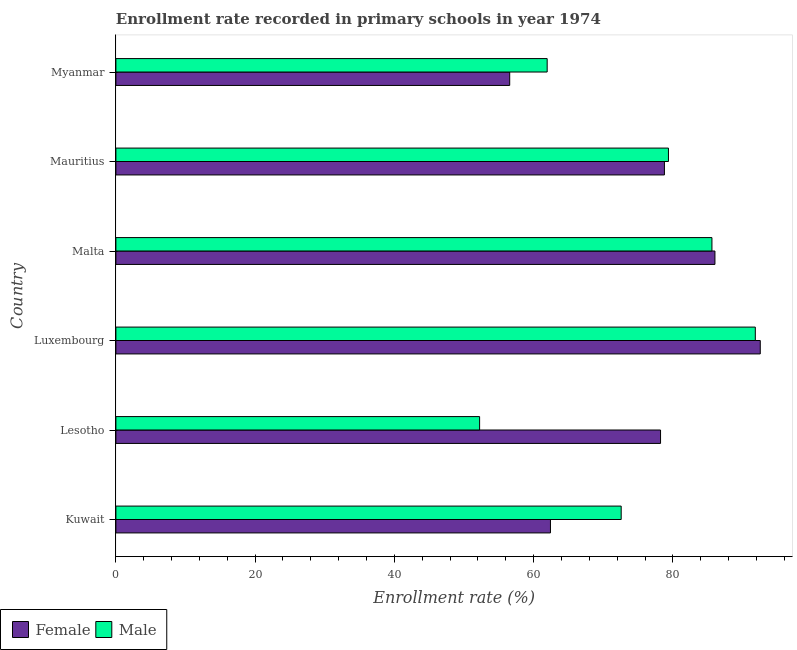How many different coloured bars are there?
Your response must be concise. 2. Are the number of bars on each tick of the Y-axis equal?
Offer a very short reply. Yes. How many bars are there on the 2nd tick from the bottom?
Your answer should be very brief. 2. What is the label of the 1st group of bars from the top?
Give a very brief answer. Myanmar. What is the enrollment rate of female students in Malta?
Make the answer very short. 86.04. Across all countries, what is the maximum enrollment rate of male students?
Provide a short and direct response. 91.84. Across all countries, what is the minimum enrollment rate of female students?
Provide a succinct answer. 56.56. In which country was the enrollment rate of male students maximum?
Give a very brief answer. Luxembourg. In which country was the enrollment rate of female students minimum?
Make the answer very short. Myanmar. What is the total enrollment rate of female students in the graph?
Provide a short and direct response. 454.59. What is the difference between the enrollment rate of female students in Lesotho and that in Malta?
Provide a succinct answer. -7.81. What is the difference between the enrollment rate of male students in Kuwait and the enrollment rate of female students in Luxembourg?
Your response must be concise. -19.98. What is the average enrollment rate of male students per country?
Keep it short and to the point. 73.93. What is the difference between the enrollment rate of female students and enrollment rate of male students in Lesotho?
Offer a terse response. 25.99. In how many countries, is the enrollment rate of male students greater than 92 %?
Provide a short and direct response. 0. What is the ratio of the enrollment rate of male students in Kuwait to that in Lesotho?
Make the answer very short. 1.39. Is the difference between the enrollment rate of female students in Luxembourg and Malta greater than the difference between the enrollment rate of male students in Luxembourg and Malta?
Offer a terse response. Yes. What is the difference between the highest and the second highest enrollment rate of male students?
Make the answer very short. 6.23. What is the difference between the highest and the lowest enrollment rate of female students?
Ensure brevity in your answer.  35.99. In how many countries, is the enrollment rate of male students greater than the average enrollment rate of male students taken over all countries?
Your answer should be very brief. 3. Is the sum of the enrollment rate of male students in Malta and Mauritius greater than the maximum enrollment rate of female students across all countries?
Keep it short and to the point. Yes. What is the difference between two consecutive major ticks on the X-axis?
Provide a succinct answer. 20. Does the graph contain any zero values?
Give a very brief answer. No. How many legend labels are there?
Offer a terse response. 2. What is the title of the graph?
Ensure brevity in your answer.  Enrollment rate recorded in primary schools in year 1974. What is the label or title of the X-axis?
Your answer should be very brief. Enrollment rate (%). What is the Enrollment rate (%) in Female in Kuwait?
Your answer should be compact. 62.42. What is the Enrollment rate (%) in Male in Kuwait?
Offer a very short reply. 72.58. What is the Enrollment rate (%) of Female in Lesotho?
Provide a succinct answer. 78.23. What is the Enrollment rate (%) in Male in Lesotho?
Your response must be concise. 52.24. What is the Enrollment rate (%) in Female in Luxembourg?
Your answer should be very brief. 92.55. What is the Enrollment rate (%) in Male in Luxembourg?
Provide a short and direct response. 91.84. What is the Enrollment rate (%) of Female in Malta?
Offer a very short reply. 86.04. What is the Enrollment rate (%) in Male in Malta?
Offer a terse response. 85.61. What is the Enrollment rate (%) in Female in Mauritius?
Ensure brevity in your answer.  78.79. What is the Enrollment rate (%) in Male in Mauritius?
Provide a succinct answer. 79.36. What is the Enrollment rate (%) in Female in Myanmar?
Offer a very short reply. 56.56. What is the Enrollment rate (%) of Male in Myanmar?
Offer a very short reply. 61.95. Across all countries, what is the maximum Enrollment rate (%) in Female?
Ensure brevity in your answer.  92.55. Across all countries, what is the maximum Enrollment rate (%) in Male?
Offer a terse response. 91.84. Across all countries, what is the minimum Enrollment rate (%) in Female?
Give a very brief answer. 56.56. Across all countries, what is the minimum Enrollment rate (%) in Male?
Your answer should be very brief. 52.24. What is the total Enrollment rate (%) in Female in the graph?
Your answer should be very brief. 454.59. What is the total Enrollment rate (%) of Male in the graph?
Keep it short and to the point. 443.58. What is the difference between the Enrollment rate (%) in Female in Kuwait and that in Lesotho?
Offer a terse response. -15.81. What is the difference between the Enrollment rate (%) of Male in Kuwait and that in Lesotho?
Your response must be concise. 20.33. What is the difference between the Enrollment rate (%) in Female in Kuwait and that in Luxembourg?
Provide a short and direct response. -30.14. What is the difference between the Enrollment rate (%) of Male in Kuwait and that in Luxembourg?
Provide a short and direct response. -19.27. What is the difference between the Enrollment rate (%) of Female in Kuwait and that in Malta?
Offer a very short reply. -23.62. What is the difference between the Enrollment rate (%) of Male in Kuwait and that in Malta?
Provide a succinct answer. -13.04. What is the difference between the Enrollment rate (%) in Female in Kuwait and that in Mauritius?
Your answer should be very brief. -16.37. What is the difference between the Enrollment rate (%) of Male in Kuwait and that in Mauritius?
Provide a short and direct response. -6.79. What is the difference between the Enrollment rate (%) in Female in Kuwait and that in Myanmar?
Give a very brief answer. 5.85. What is the difference between the Enrollment rate (%) in Male in Kuwait and that in Myanmar?
Your answer should be compact. 10.63. What is the difference between the Enrollment rate (%) in Female in Lesotho and that in Luxembourg?
Offer a very short reply. -14.32. What is the difference between the Enrollment rate (%) in Male in Lesotho and that in Luxembourg?
Keep it short and to the point. -39.6. What is the difference between the Enrollment rate (%) in Female in Lesotho and that in Malta?
Your answer should be compact. -7.81. What is the difference between the Enrollment rate (%) in Male in Lesotho and that in Malta?
Ensure brevity in your answer.  -33.37. What is the difference between the Enrollment rate (%) of Female in Lesotho and that in Mauritius?
Ensure brevity in your answer.  -0.56. What is the difference between the Enrollment rate (%) of Male in Lesotho and that in Mauritius?
Your response must be concise. -27.12. What is the difference between the Enrollment rate (%) in Female in Lesotho and that in Myanmar?
Make the answer very short. 21.67. What is the difference between the Enrollment rate (%) in Male in Lesotho and that in Myanmar?
Give a very brief answer. -9.7. What is the difference between the Enrollment rate (%) in Female in Luxembourg and that in Malta?
Keep it short and to the point. 6.51. What is the difference between the Enrollment rate (%) of Male in Luxembourg and that in Malta?
Provide a succinct answer. 6.23. What is the difference between the Enrollment rate (%) in Female in Luxembourg and that in Mauritius?
Your response must be concise. 13.77. What is the difference between the Enrollment rate (%) of Male in Luxembourg and that in Mauritius?
Your answer should be very brief. 12.48. What is the difference between the Enrollment rate (%) of Female in Luxembourg and that in Myanmar?
Provide a short and direct response. 35.99. What is the difference between the Enrollment rate (%) in Male in Luxembourg and that in Myanmar?
Provide a succinct answer. 29.9. What is the difference between the Enrollment rate (%) in Female in Malta and that in Mauritius?
Offer a very short reply. 7.26. What is the difference between the Enrollment rate (%) of Male in Malta and that in Mauritius?
Provide a succinct answer. 6.25. What is the difference between the Enrollment rate (%) of Female in Malta and that in Myanmar?
Keep it short and to the point. 29.48. What is the difference between the Enrollment rate (%) in Male in Malta and that in Myanmar?
Offer a terse response. 23.67. What is the difference between the Enrollment rate (%) of Female in Mauritius and that in Myanmar?
Give a very brief answer. 22.22. What is the difference between the Enrollment rate (%) of Male in Mauritius and that in Myanmar?
Ensure brevity in your answer.  17.42. What is the difference between the Enrollment rate (%) in Female in Kuwait and the Enrollment rate (%) in Male in Lesotho?
Your response must be concise. 10.18. What is the difference between the Enrollment rate (%) in Female in Kuwait and the Enrollment rate (%) in Male in Luxembourg?
Provide a succinct answer. -29.42. What is the difference between the Enrollment rate (%) of Female in Kuwait and the Enrollment rate (%) of Male in Malta?
Your answer should be very brief. -23.19. What is the difference between the Enrollment rate (%) of Female in Kuwait and the Enrollment rate (%) of Male in Mauritius?
Provide a short and direct response. -16.95. What is the difference between the Enrollment rate (%) in Female in Kuwait and the Enrollment rate (%) in Male in Myanmar?
Offer a terse response. 0.47. What is the difference between the Enrollment rate (%) of Female in Lesotho and the Enrollment rate (%) of Male in Luxembourg?
Your response must be concise. -13.61. What is the difference between the Enrollment rate (%) in Female in Lesotho and the Enrollment rate (%) in Male in Malta?
Offer a terse response. -7.38. What is the difference between the Enrollment rate (%) of Female in Lesotho and the Enrollment rate (%) of Male in Mauritius?
Keep it short and to the point. -1.13. What is the difference between the Enrollment rate (%) of Female in Lesotho and the Enrollment rate (%) of Male in Myanmar?
Provide a succinct answer. 16.28. What is the difference between the Enrollment rate (%) of Female in Luxembourg and the Enrollment rate (%) of Male in Malta?
Offer a terse response. 6.94. What is the difference between the Enrollment rate (%) in Female in Luxembourg and the Enrollment rate (%) in Male in Mauritius?
Offer a terse response. 13.19. What is the difference between the Enrollment rate (%) of Female in Luxembourg and the Enrollment rate (%) of Male in Myanmar?
Make the answer very short. 30.61. What is the difference between the Enrollment rate (%) of Female in Malta and the Enrollment rate (%) of Male in Mauritius?
Your response must be concise. 6.68. What is the difference between the Enrollment rate (%) of Female in Malta and the Enrollment rate (%) of Male in Myanmar?
Ensure brevity in your answer.  24.1. What is the difference between the Enrollment rate (%) in Female in Mauritius and the Enrollment rate (%) in Male in Myanmar?
Your answer should be very brief. 16.84. What is the average Enrollment rate (%) of Female per country?
Provide a succinct answer. 75.76. What is the average Enrollment rate (%) in Male per country?
Provide a succinct answer. 73.93. What is the difference between the Enrollment rate (%) of Female and Enrollment rate (%) of Male in Kuwait?
Your response must be concise. -10.16. What is the difference between the Enrollment rate (%) of Female and Enrollment rate (%) of Male in Lesotho?
Offer a very short reply. 25.99. What is the difference between the Enrollment rate (%) of Female and Enrollment rate (%) of Male in Luxembourg?
Keep it short and to the point. 0.71. What is the difference between the Enrollment rate (%) of Female and Enrollment rate (%) of Male in Malta?
Provide a succinct answer. 0.43. What is the difference between the Enrollment rate (%) in Female and Enrollment rate (%) in Male in Mauritius?
Provide a short and direct response. -0.58. What is the difference between the Enrollment rate (%) in Female and Enrollment rate (%) in Male in Myanmar?
Offer a terse response. -5.38. What is the ratio of the Enrollment rate (%) of Female in Kuwait to that in Lesotho?
Offer a very short reply. 0.8. What is the ratio of the Enrollment rate (%) in Male in Kuwait to that in Lesotho?
Your answer should be very brief. 1.39. What is the ratio of the Enrollment rate (%) of Female in Kuwait to that in Luxembourg?
Provide a short and direct response. 0.67. What is the ratio of the Enrollment rate (%) of Male in Kuwait to that in Luxembourg?
Provide a short and direct response. 0.79. What is the ratio of the Enrollment rate (%) in Female in Kuwait to that in Malta?
Keep it short and to the point. 0.73. What is the ratio of the Enrollment rate (%) in Male in Kuwait to that in Malta?
Your response must be concise. 0.85. What is the ratio of the Enrollment rate (%) of Female in Kuwait to that in Mauritius?
Your response must be concise. 0.79. What is the ratio of the Enrollment rate (%) of Male in Kuwait to that in Mauritius?
Provide a succinct answer. 0.91. What is the ratio of the Enrollment rate (%) in Female in Kuwait to that in Myanmar?
Provide a succinct answer. 1.1. What is the ratio of the Enrollment rate (%) of Male in Kuwait to that in Myanmar?
Provide a short and direct response. 1.17. What is the ratio of the Enrollment rate (%) in Female in Lesotho to that in Luxembourg?
Ensure brevity in your answer.  0.85. What is the ratio of the Enrollment rate (%) of Male in Lesotho to that in Luxembourg?
Make the answer very short. 0.57. What is the ratio of the Enrollment rate (%) in Female in Lesotho to that in Malta?
Give a very brief answer. 0.91. What is the ratio of the Enrollment rate (%) in Male in Lesotho to that in Malta?
Keep it short and to the point. 0.61. What is the ratio of the Enrollment rate (%) in Female in Lesotho to that in Mauritius?
Offer a very short reply. 0.99. What is the ratio of the Enrollment rate (%) in Male in Lesotho to that in Mauritius?
Your response must be concise. 0.66. What is the ratio of the Enrollment rate (%) in Female in Lesotho to that in Myanmar?
Your answer should be compact. 1.38. What is the ratio of the Enrollment rate (%) in Male in Lesotho to that in Myanmar?
Give a very brief answer. 0.84. What is the ratio of the Enrollment rate (%) in Female in Luxembourg to that in Malta?
Keep it short and to the point. 1.08. What is the ratio of the Enrollment rate (%) in Male in Luxembourg to that in Malta?
Make the answer very short. 1.07. What is the ratio of the Enrollment rate (%) in Female in Luxembourg to that in Mauritius?
Offer a terse response. 1.17. What is the ratio of the Enrollment rate (%) in Male in Luxembourg to that in Mauritius?
Make the answer very short. 1.16. What is the ratio of the Enrollment rate (%) of Female in Luxembourg to that in Myanmar?
Offer a very short reply. 1.64. What is the ratio of the Enrollment rate (%) in Male in Luxembourg to that in Myanmar?
Give a very brief answer. 1.48. What is the ratio of the Enrollment rate (%) in Female in Malta to that in Mauritius?
Make the answer very short. 1.09. What is the ratio of the Enrollment rate (%) in Male in Malta to that in Mauritius?
Give a very brief answer. 1.08. What is the ratio of the Enrollment rate (%) of Female in Malta to that in Myanmar?
Your answer should be very brief. 1.52. What is the ratio of the Enrollment rate (%) of Male in Malta to that in Myanmar?
Offer a terse response. 1.38. What is the ratio of the Enrollment rate (%) in Female in Mauritius to that in Myanmar?
Provide a short and direct response. 1.39. What is the ratio of the Enrollment rate (%) of Male in Mauritius to that in Myanmar?
Provide a succinct answer. 1.28. What is the difference between the highest and the second highest Enrollment rate (%) of Female?
Make the answer very short. 6.51. What is the difference between the highest and the second highest Enrollment rate (%) of Male?
Your answer should be very brief. 6.23. What is the difference between the highest and the lowest Enrollment rate (%) in Female?
Provide a short and direct response. 35.99. What is the difference between the highest and the lowest Enrollment rate (%) in Male?
Offer a terse response. 39.6. 